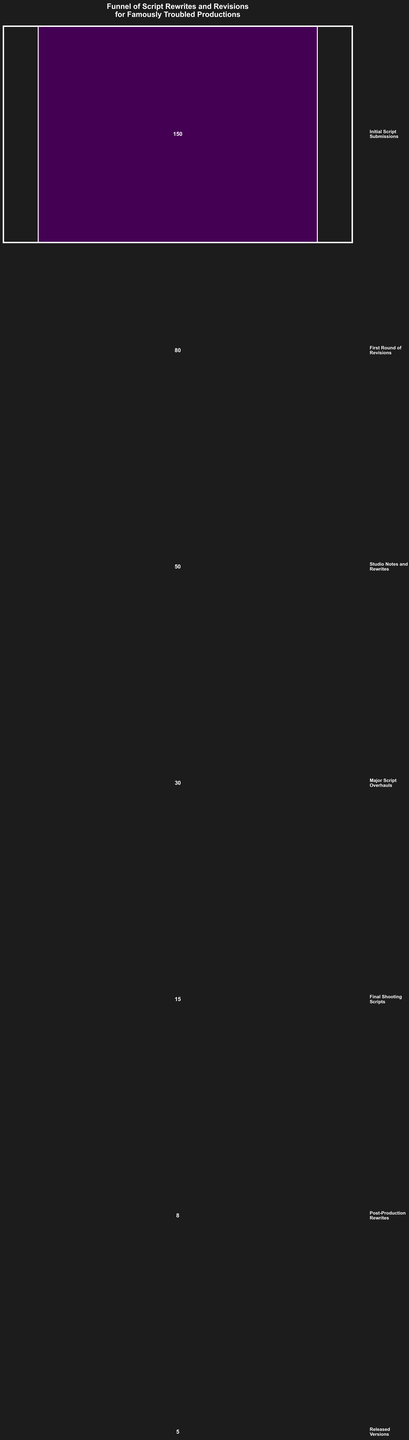what is the title of the chart? The title of the chart is displayed prominently at the top. It reads "Funnel of Script Rewrites and Revisions for Famously Troubled Productions".
Answer: Funnel of Script Rewrites and Revisions for Famously Troubled Productions how many stages does the funnel chart have? Counting the distinct horizontal sections from top to bottom, the chart consists of 7 stages.
Answer: 7 which stage has the highest number of scripts? The top section of the funnel, labeled as "Initial Script Submissions," shows the highest number of scripts, which is 150.
Answer: Initial Script Submissions (150) how many scripts were there after the first round of revisions? The second section from the top is labeled "First Round of Revisions," which has 80 scripts.
Answer: 80 how many scripts were further revised after the studio notes and rewrites stage? By observing the drop from the "Studio Notes and Rewrites" stage (50 scripts) to the "Major Script Overhauls" stage (30 scripts), 20 scripts were further revised.
Answer: 20 by how much did the number of scripts decrease from the final shooting scripts stage to the post-production rewrites stage? The "Final Shooting Scripts" stage has 15 scripts and the "Post-Production Rewrites" stage has 8 scripts. The decrease is calculated as 15 - 8 = 7 scripts.
Answer: 7 what percentage of initial script submissions reached the released versions stage? There are 150 initial script submissions and 5 released versions. The percentage is calculated as (5/150) * 100 = 3.33%.
Answer: 3.33% are there more scripts at the studio notes and rewrites stage or the major script overhauls stage? Comparing the values, the "Studio Notes and Rewrites" stage has 50 scripts, while the "Major Script Overhauls" stage has 30 scripts. Therefore, there are more scripts at the "Studio Notes and Rewrites" stage.
Answer: Studio Notes and Rewrites (50) what is the median number of scripts across all stages? The number of scripts in each stage are: 150, 80, 50, 30, 15, 8, 5. Arranging them in ascending order: 5, 8, 15, 30, 50, 80, 150. The median is the middle value, which is 30.
Answer: 30 how many scripts were discarded between the final shooting scripts stage and the released versions stage? The number of scripts dropped from the "Final Shooting Scripts" stage (15 scripts) to the "Released Versions" stage (5 scripts). The difference is 15 - 5 = 10 scripts.
Answer: 10 